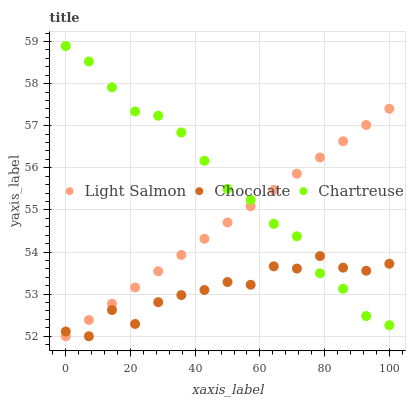Does Chocolate have the minimum area under the curve?
Answer yes or no. Yes. Does Chartreuse have the maximum area under the curve?
Answer yes or no. Yes. Does Chartreuse have the minimum area under the curve?
Answer yes or no. No. Does Chocolate have the maximum area under the curve?
Answer yes or no. No. Is Light Salmon the smoothest?
Answer yes or no. Yes. Is Chocolate the roughest?
Answer yes or no. Yes. Is Chartreuse the smoothest?
Answer yes or no. No. Is Chartreuse the roughest?
Answer yes or no. No. Does Light Salmon have the lowest value?
Answer yes or no. Yes. Does Chartreuse have the lowest value?
Answer yes or no. No. Does Chartreuse have the highest value?
Answer yes or no. Yes. Does Chocolate have the highest value?
Answer yes or no. No. Does Chartreuse intersect Light Salmon?
Answer yes or no. Yes. Is Chartreuse less than Light Salmon?
Answer yes or no. No. Is Chartreuse greater than Light Salmon?
Answer yes or no. No. 